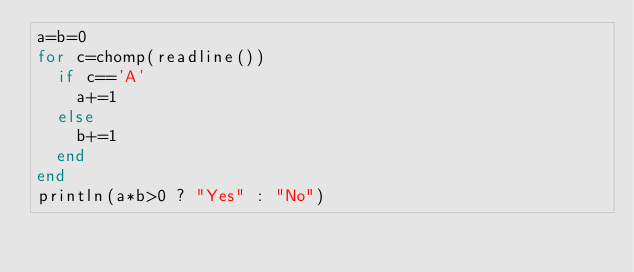Convert code to text. <code><loc_0><loc_0><loc_500><loc_500><_Julia_>a=b=0
for c=chomp(readline())
  if c=='A'
    a+=1
  else
    b+=1
  end
end
println(a*b>0 ? "Yes" : "No")</code> 